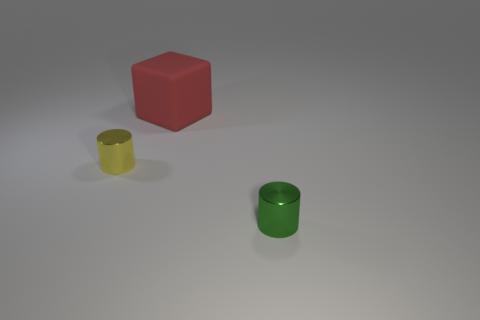Is there anything else that is made of the same material as the large thing?
Provide a succinct answer. No. Are there fewer yellow metal cylinders that are behind the yellow shiny thing than big matte objects that are to the left of the tiny green shiny thing?
Make the answer very short. Yes. What is the tiny cylinder that is left of the small object in front of the metallic cylinder that is left of the matte thing made of?
Offer a terse response. Metal. There is a object that is both in front of the rubber block and to the right of the tiny yellow cylinder; how big is it?
Make the answer very short. Small. What number of balls are matte things or tiny green objects?
Give a very brief answer. 0. What color is the shiny cylinder that is the same size as the yellow object?
Your answer should be very brief. Green. Is there any other thing that has the same shape as the tiny yellow thing?
Provide a short and direct response. Yes. There is another tiny thing that is the same shape as the tiny yellow thing; what is its color?
Your response must be concise. Green. What number of objects are cylinders or tiny shiny objects to the right of the cube?
Your answer should be compact. 2. Is the number of large red matte blocks in front of the green object less than the number of small green objects?
Ensure brevity in your answer.  Yes. 